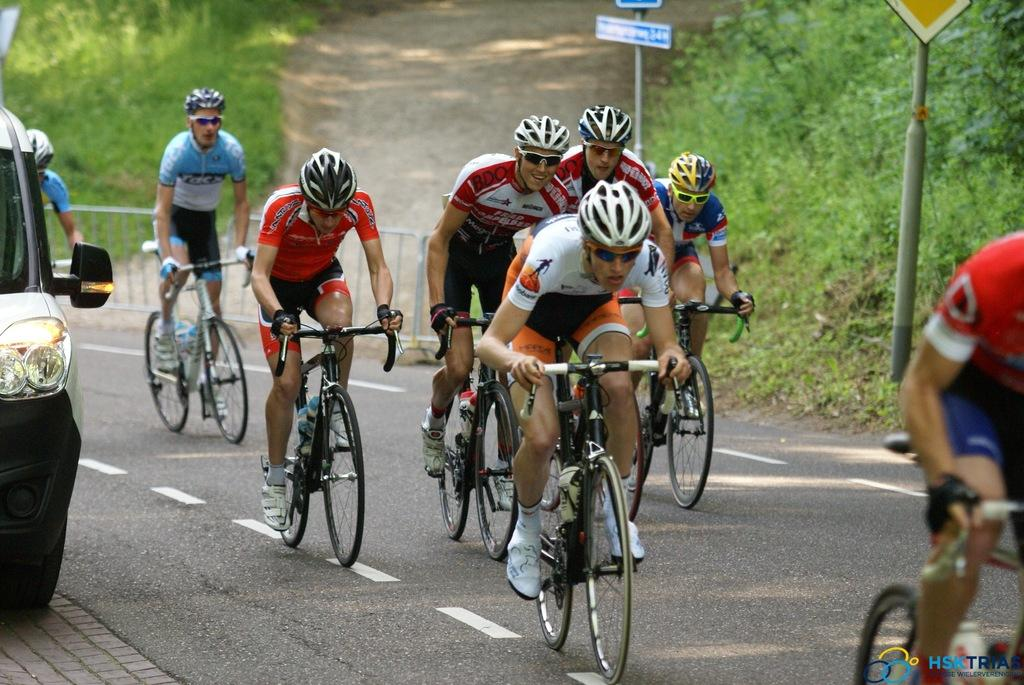What activity are the people in the image engaged in? The people in the image are riding a bicycle. What can be seen on the left side of the image? There is a car on the left side of the image. What type of vegetation is visible in the background of the image? There are plants visible in the background of the image. How many rabbits are playing with a marble on the bicycle in the image? There are no rabbits or marbles present in the image; it features people riding a bicycle and a car on the left side. 